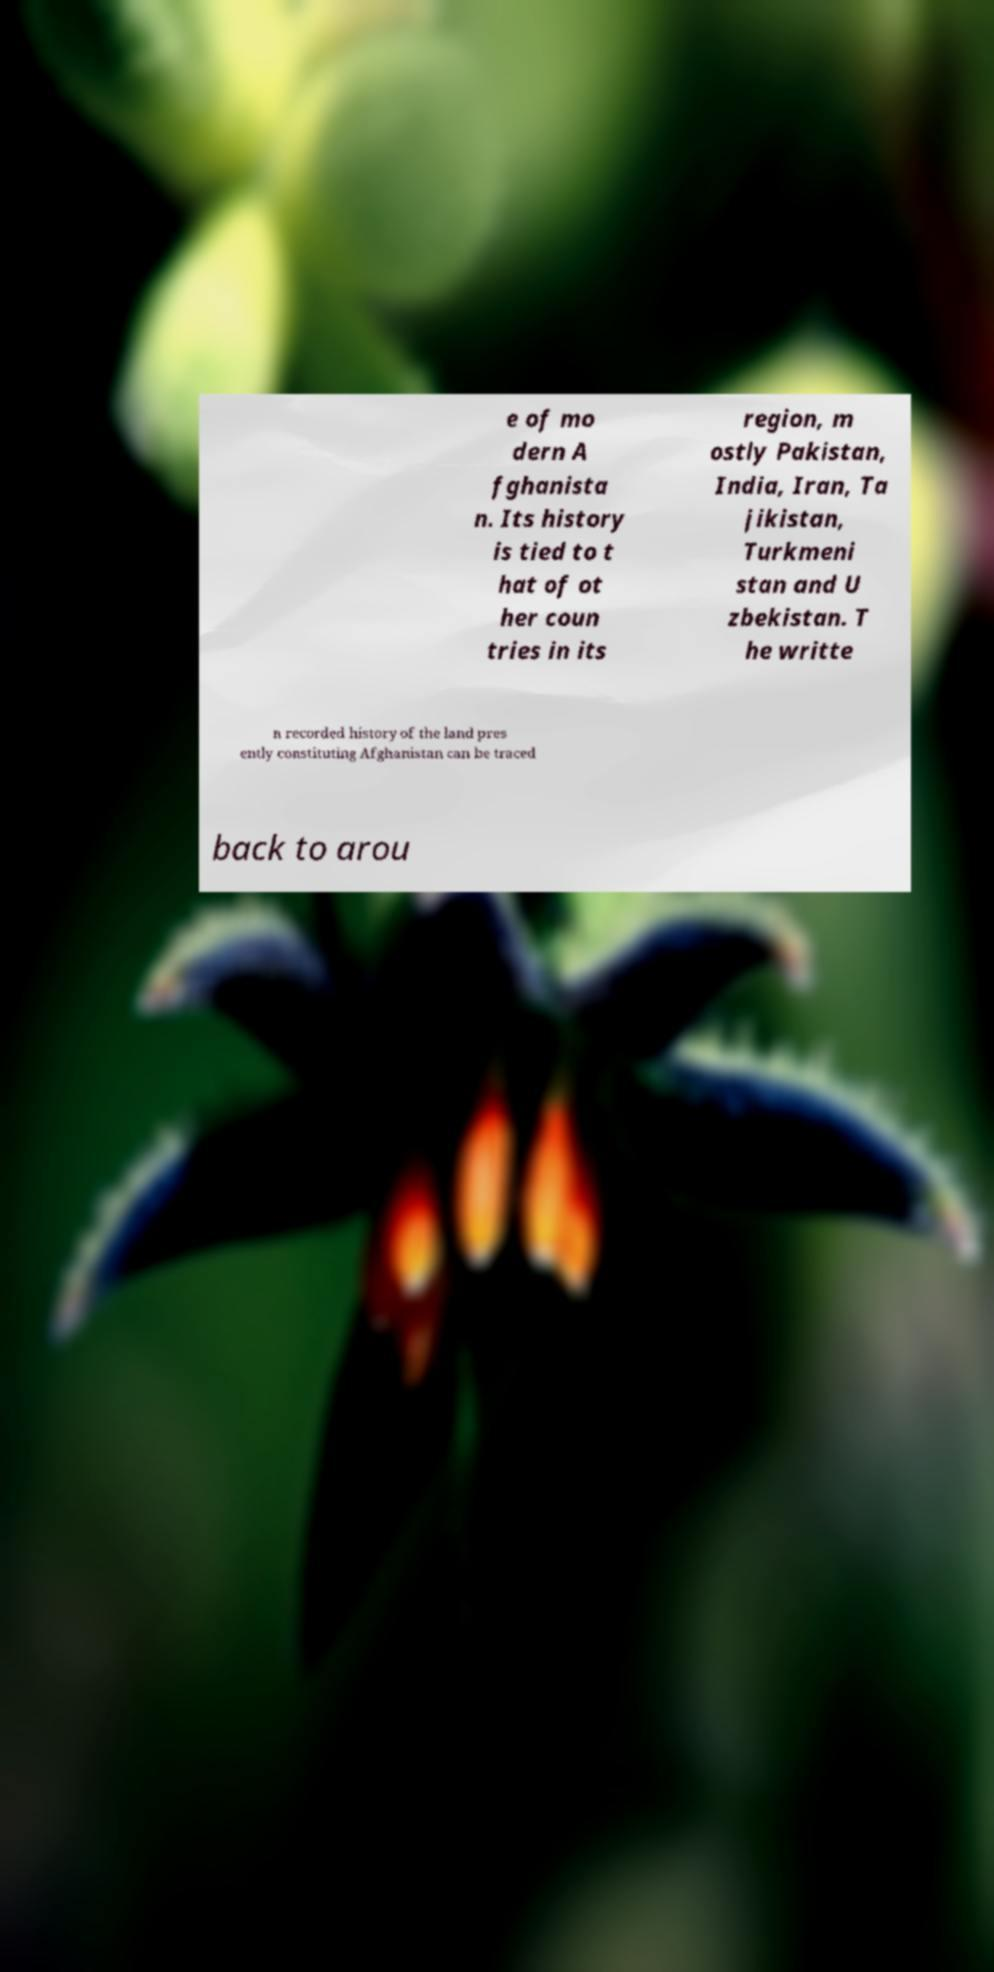Could you extract and type out the text from this image? e of mo dern A fghanista n. Its history is tied to t hat of ot her coun tries in its region, m ostly Pakistan, India, Iran, Ta jikistan, Turkmeni stan and U zbekistan. T he writte n recorded history of the land pres ently constituting Afghanistan can be traced back to arou 